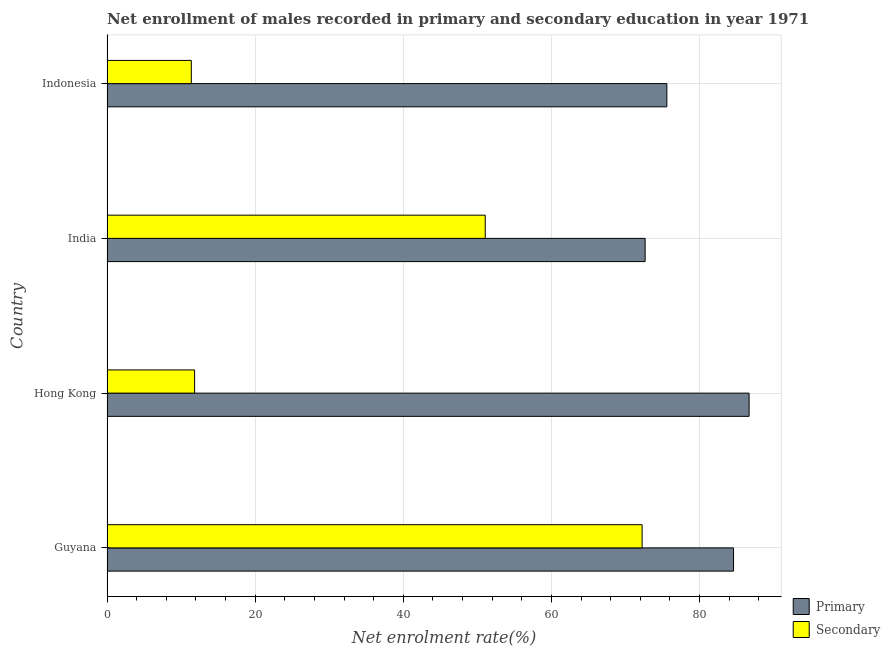How many different coloured bars are there?
Provide a succinct answer. 2. Are the number of bars per tick equal to the number of legend labels?
Provide a succinct answer. Yes. Are the number of bars on each tick of the Y-axis equal?
Your answer should be compact. Yes. How many bars are there on the 3rd tick from the top?
Ensure brevity in your answer.  2. How many bars are there on the 1st tick from the bottom?
Your response must be concise. 2. What is the label of the 3rd group of bars from the top?
Provide a succinct answer. Hong Kong. What is the enrollment rate in secondary education in India?
Keep it short and to the point. 51.06. Across all countries, what is the maximum enrollment rate in primary education?
Your answer should be compact. 86.69. Across all countries, what is the minimum enrollment rate in secondary education?
Offer a very short reply. 11.38. In which country was the enrollment rate in secondary education maximum?
Offer a terse response. Guyana. In which country was the enrollment rate in secondary education minimum?
Offer a very short reply. Indonesia. What is the total enrollment rate in secondary education in the graph?
Ensure brevity in your answer.  146.52. What is the difference between the enrollment rate in primary education in Guyana and that in Indonesia?
Offer a very short reply. 9.01. What is the difference between the enrollment rate in secondary education in Guyana and the enrollment rate in primary education in Indonesia?
Ensure brevity in your answer.  -3.34. What is the average enrollment rate in primary education per country?
Offer a terse response. 79.88. What is the difference between the enrollment rate in primary education and enrollment rate in secondary education in Guyana?
Keep it short and to the point. 12.34. In how many countries, is the enrollment rate in primary education greater than 48 %?
Offer a very short reply. 4. What is the ratio of the enrollment rate in primary education in Guyana to that in Indonesia?
Ensure brevity in your answer.  1.12. Is the difference between the enrollment rate in secondary education in Hong Kong and India greater than the difference between the enrollment rate in primary education in Hong Kong and India?
Make the answer very short. No. What is the difference between the highest and the second highest enrollment rate in secondary education?
Your response must be concise. 21.18. What is the difference between the highest and the lowest enrollment rate in secondary education?
Your response must be concise. 60.86. What does the 2nd bar from the top in India represents?
Provide a succinct answer. Primary. What does the 2nd bar from the bottom in India represents?
Your response must be concise. Secondary. How many bars are there?
Keep it short and to the point. 8. Does the graph contain any zero values?
Offer a terse response. No. Where does the legend appear in the graph?
Offer a very short reply. Bottom right. What is the title of the graph?
Your answer should be compact. Net enrollment of males recorded in primary and secondary education in year 1971. What is the label or title of the X-axis?
Offer a very short reply. Net enrolment rate(%). What is the label or title of the Y-axis?
Give a very brief answer. Country. What is the Net enrolment rate(%) of Primary in Guyana?
Provide a succinct answer. 84.59. What is the Net enrolment rate(%) in Secondary in Guyana?
Make the answer very short. 72.24. What is the Net enrolment rate(%) in Primary in Hong Kong?
Offer a terse response. 86.69. What is the Net enrolment rate(%) of Secondary in Hong Kong?
Your answer should be compact. 11.83. What is the Net enrolment rate(%) of Primary in India?
Offer a very short reply. 72.65. What is the Net enrolment rate(%) in Secondary in India?
Give a very brief answer. 51.06. What is the Net enrolment rate(%) of Primary in Indonesia?
Your answer should be compact. 75.58. What is the Net enrolment rate(%) in Secondary in Indonesia?
Offer a terse response. 11.38. Across all countries, what is the maximum Net enrolment rate(%) of Primary?
Give a very brief answer. 86.69. Across all countries, what is the maximum Net enrolment rate(%) of Secondary?
Keep it short and to the point. 72.24. Across all countries, what is the minimum Net enrolment rate(%) in Primary?
Your answer should be compact. 72.65. Across all countries, what is the minimum Net enrolment rate(%) of Secondary?
Ensure brevity in your answer.  11.38. What is the total Net enrolment rate(%) in Primary in the graph?
Make the answer very short. 319.51. What is the total Net enrolment rate(%) in Secondary in the graph?
Offer a very short reply. 146.52. What is the difference between the Net enrolment rate(%) in Primary in Guyana and that in Hong Kong?
Keep it short and to the point. -2.1. What is the difference between the Net enrolment rate(%) of Secondary in Guyana and that in Hong Kong?
Your answer should be compact. 60.42. What is the difference between the Net enrolment rate(%) of Primary in Guyana and that in India?
Offer a terse response. 11.93. What is the difference between the Net enrolment rate(%) in Secondary in Guyana and that in India?
Provide a short and direct response. 21.18. What is the difference between the Net enrolment rate(%) in Primary in Guyana and that in Indonesia?
Offer a very short reply. 9. What is the difference between the Net enrolment rate(%) in Secondary in Guyana and that in Indonesia?
Offer a terse response. 60.86. What is the difference between the Net enrolment rate(%) of Primary in Hong Kong and that in India?
Provide a short and direct response. 14.04. What is the difference between the Net enrolment rate(%) in Secondary in Hong Kong and that in India?
Your answer should be compact. -39.24. What is the difference between the Net enrolment rate(%) of Primary in Hong Kong and that in Indonesia?
Provide a succinct answer. 11.11. What is the difference between the Net enrolment rate(%) of Secondary in Hong Kong and that in Indonesia?
Provide a short and direct response. 0.45. What is the difference between the Net enrolment rate(%) in Primary in India and that in Indonesia?
Your response must be concise. -2.93. What is the difference between the Net enrolment rate(%) of Secondary in India and that in Indonesia?
Provide a succinct answer. 39.68. What is the difference between the Net enrolment rate(%) of Primary in Guyana and the Net enrolment rate(%) of Secondary in Hong Kong?
Give a very brief answer. 72.76. What is the difference between the Net enrolment rate(%) in Primary in Guyana and the Net enrolment rate(%) in Secondary in India?
Ensure brevity in your answer.  33.52. What is the difference between the Net enrolment rate(%) of Primary in Guyana and the Net enrolment rate(%) of Secondary in Indonesia?
Offer a terse response. 73.21. What is the difference between the Net enrolment rate(%) in Primary in Hong Kong and the Net enrolment rate(%) in Secondary in India?
Offer a very short reply. 35.62. What is the difference between the Net enrolment rate(%) in Primary in Hong Kong and the Net enrolment rate(%) in Secondary in Indonesia?
Make the answer very short. 75.31. What is the difference between the Net enrolment rate(%) in Primary in India and the Net enrolment rate(%) in Secondary in Indonesia?
Your answer should be very brief. 61.27. What is the average Net enrolment rate(%) in Primary per country?
Your answer should be compact. 79.88. What is the average Net enrolment rate(%) in Secondary per country?
Your response must be concise. 36.63. What is the difference between the Net enrolment rate(%) in Primary and Net enrolment rate(%) in Secondary in Guyana?
Your answer should be compact. 12.34. What is the difference between the Net enrolment rate(%) of Primary and Net enrolment rate(%) of Secondary in Hong Kong?
Keep it short and to the point. 74.86. What is the difference between the Net enrolment rate(%) of Primary and Net enrolment rate(%) of Secondary in India?
Give a very brief answer. 21.59. What is the difference between the Net enrolment rate(%) of Primary and Net enrolment rate(%) of Secondary in Indonesia?
Your answer should be very brief. 64.2. What is the ratio of the Net enrolment rate(%) of Primary in Guyana to that in Hong Kong?
Offer a very short reply. 0.98. What is the ratio of the Net enrolment rate(%) in Secondary in Guyana to that in Hong Kong?
Make the answer very short. 6.11. What is the ratio of the Net enrolment rate(%) of Primary in Guyana to that in India?
Your response must be concise. 1.16. What is the ratio of the Net enrolment rate(%) in Secondary in Guyana to that in India?
Offer a terse response. 1.41. What is the ratio of the Net enrolment rate(%) of Primary in Guyana to that in Indonesia?
Offer a very short reply. 1.12. What is the ratio of the Net enrolment rate(%) in Secondary in Guyana to that in Indonesia?
Offer a terse response. 6.35. What is the ratio of the Net enrolment rate(%) of Primary in Hong Kong to that in India?
Offer a terse response. 1.19. What is the ratio of the Net enrolment rate(%) in Secondary in Hong Kong to that in India?
Keep it short and to the point. 0.23. What is the ratio of the Net enrolment rate(%) in Primary in Hong Kong to that in Indonesia?
Your response must be concise. 1.15. What is the ratio of the Net enrolment rate(%) in Secondary in Hong Kong to that in Indonesia?
Ensure brevity in your answer.  1.04. What is the ratio of the Net enrolment rate(%) in Primary in India to that in Indonesia?
Keep it short and to the point. 0.96. What is the ratio of the Net enrolment rate(%) in Secondary in India to that in Indonesia?
Offer a very short reply. 4.49. What is the difference between the highest and the second highest Net enrolment rate(%) in Primary?
Provide a short and direct response. 2.1. What is the difference between the highest and the second highest Net enrolment rate(%) of Secondary?
Your answer should be very brief. 21.18. What is the difference between the highest and the lowest Net enrolment rate(%) in Primary?
Offer a terse response. 14.04. What is the difference between the highest and the lowest Net enrolment rate(%) of Secondary?
Give a very brief answer. 60.86. 